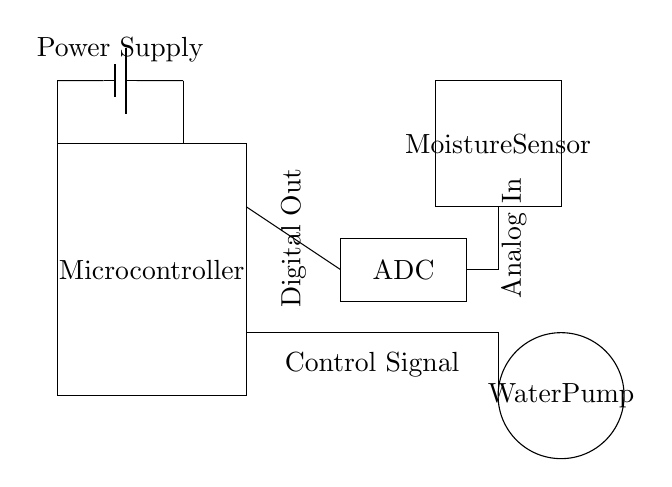What components are present in the circuit? The components visible in the diagram are a microcontroller, a moisture sensor, an ADC, and a water pump, all of which contribute to the functioning of the automated plant watering system.
Answer: microcontroller, moisture sensor, ADC, water pump What type of signal does the microcontroller receive from the moisture sensor? The moisture sensor provides an analog signal to the microcontroller through the ADC (Analog-to-Digital Converter), indicating the moisture level detected by the sensor.
Answer: analog signal Which component is responsible for converting the sensor signal? The ADC (Analog-to-Digital Converter) is responsible for converting the analog signal from the moisture sensor into a digital signal that the microcontroller can process.
Answer: ADC What is the function of the water pump in this circuit? The water pump is activated based on the moisture level detected by the moisture sensor, and when the soil is dry, it distributes water to the plant, automating the watering process.
Answer: distribute water What type of power supply is used in this circuit? The circuit features a battery power supply, as indicated by the presence of a battery symbol feeding power to the components.
Answer: battery How does the moisture sensor communicate with the microcontroller? The moisture sensor communicates with the microcontroller via an analog signal sent to the ADC, which then converts that analog input into a digital format for the microcontroller to interpret.
Answer: via ADC What is indicated by the control signal in the circuit? The control signal indicates the output from the microcontroller that triggers the water pump to activate when watering is needed based on sensor readings.
Answer: activates water pump 